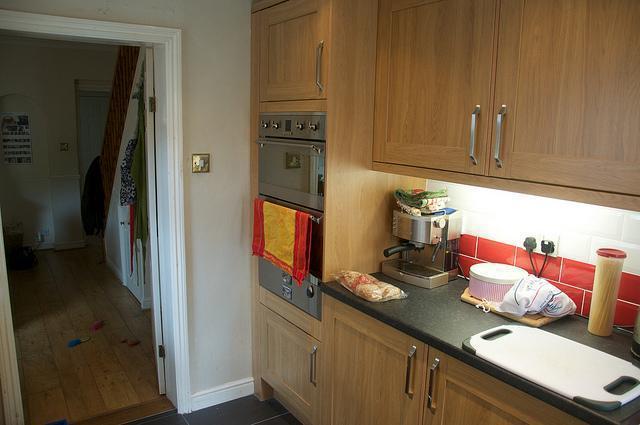How many red towels are on the oven?
Give a very brief answer. 1. 